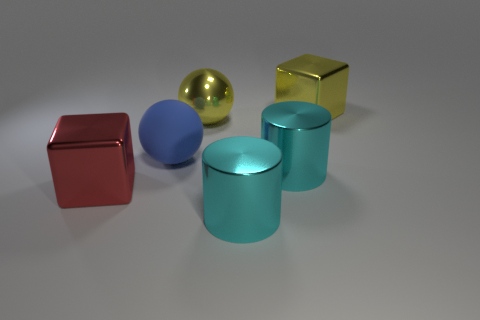Add 4 red metallic things. How many objects exist? 10 Subtract all yellow cubes. How many cubes are left? 1 Subtract all blocks. How many objects are left? 4 Subtract 1 spheres. How many spheres are left? 1 Subtract all cyan balls. Subtract all gray blocks. How many balls are left? 2 Subtract all red cylinders. How many brown cubes are left? 0 Subtract all big red things. Subtract all blocks. How many objects are left? 3 Add 6 matte objects. How many matte objects are left? 7 Add 5 large metal cylinders. How many large metal cylinders exist? 7 Subtract 1 yellow cubes. How many objects are left? 5 